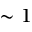Convert formula to latex. <formula><loc_0><loc_0><loc_500><loc_500>\sim 1</formula> 